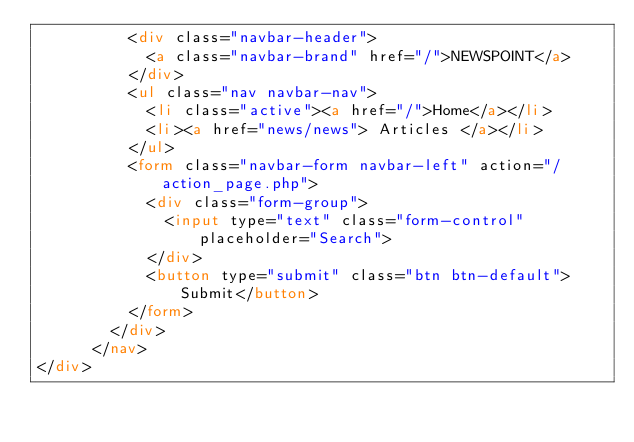Convert code to text. <code><loc_0><loc_0><loc_500><loc_500><_HTML_>          <div class="navbar-header">
            <a class="navbar-brand" href="/">NEWSPOINT</a>
          </div>
          <ul class="nav navbar-nav">
            <li class="active"><a href="/">Home</a></li>
            <li><a href="news/news"> Articles </a></li>
          </ul>
          <form class="navbar-form navbar-left" action="/action_page.php">
            <div class="form-group">
              <input type="text" class="form-control" placeholder="Search">
            </div>
            <button type="submit" class="btn btn-default">Submit</button>
          </form>
        </div>
      </nav>
</div></code> 